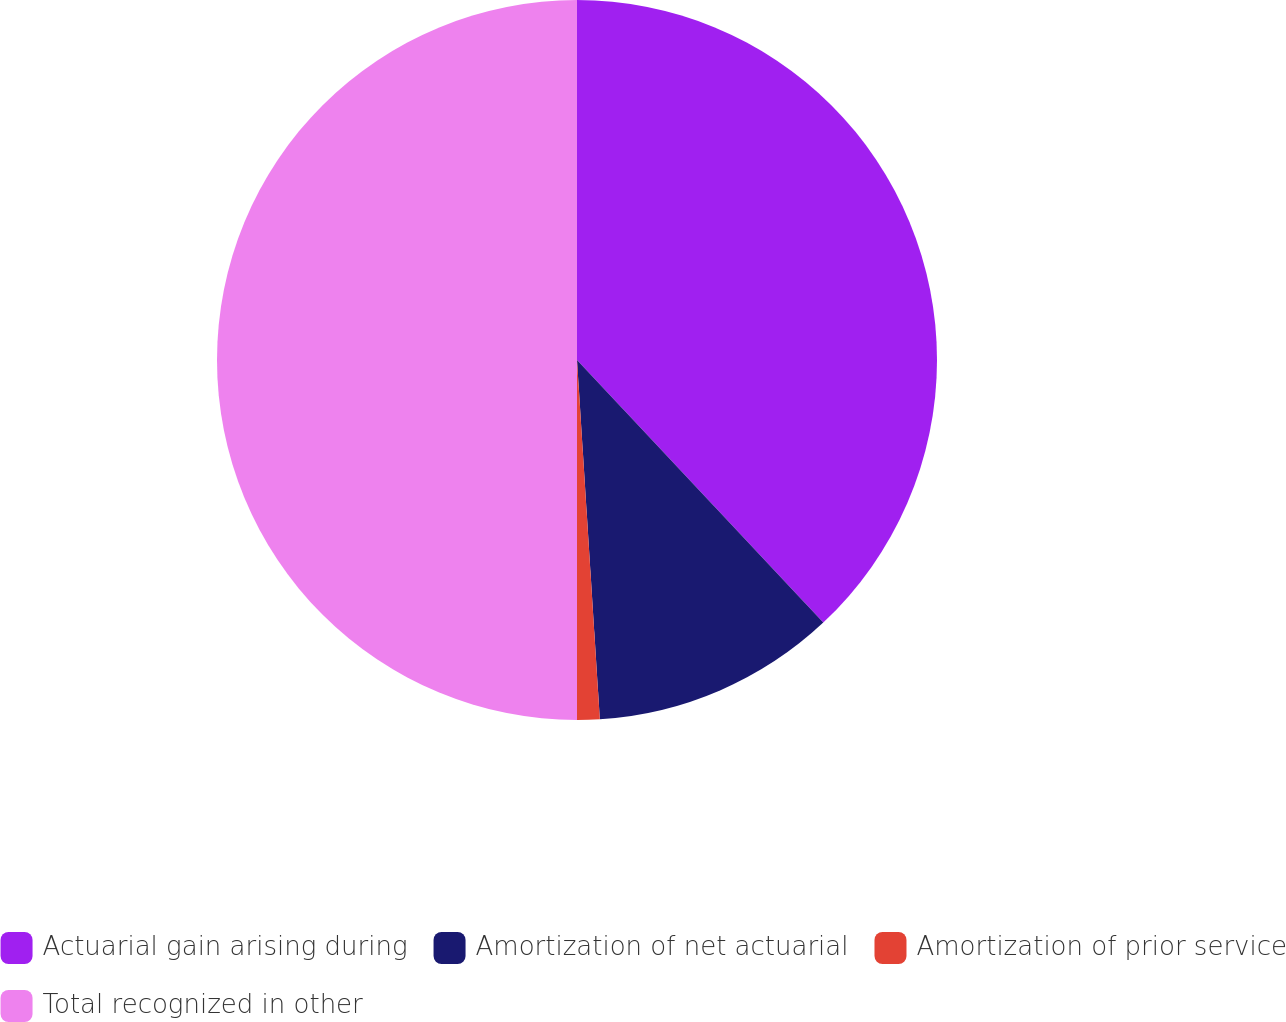Convert chart to OTSL. <chart><loc_0><loc_0><loc_500><loc_500><pie_chart><fcel>Actuarial gain arising during<fcel>Amortization of net actuarial<fcel>Amortization of prior service<fcel>Total recognized in other<nl><fcel>38.01%<fcel>10.98%<fcel>1.01%<fcel>50.0%<nl></chart> 